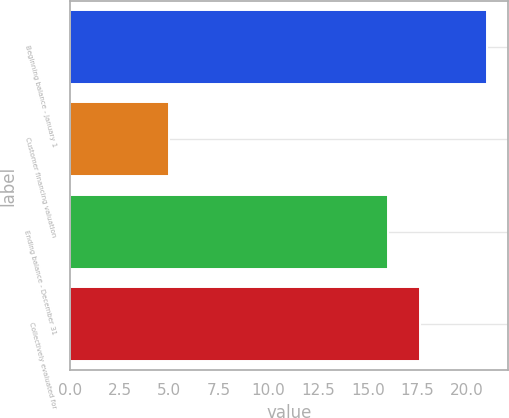Convert chart. <chart><loc_0><loc_0><loc_500><loc_500><bar_chart><fcel>Beginning balance - January 1<fcel>Customer financing valuation<fcel>Ending balance - December 31<fcel>Collectively evaluated for<nl><fcel>21<fcel>5<fcel>16<fcel>17.6<nl></chart> 